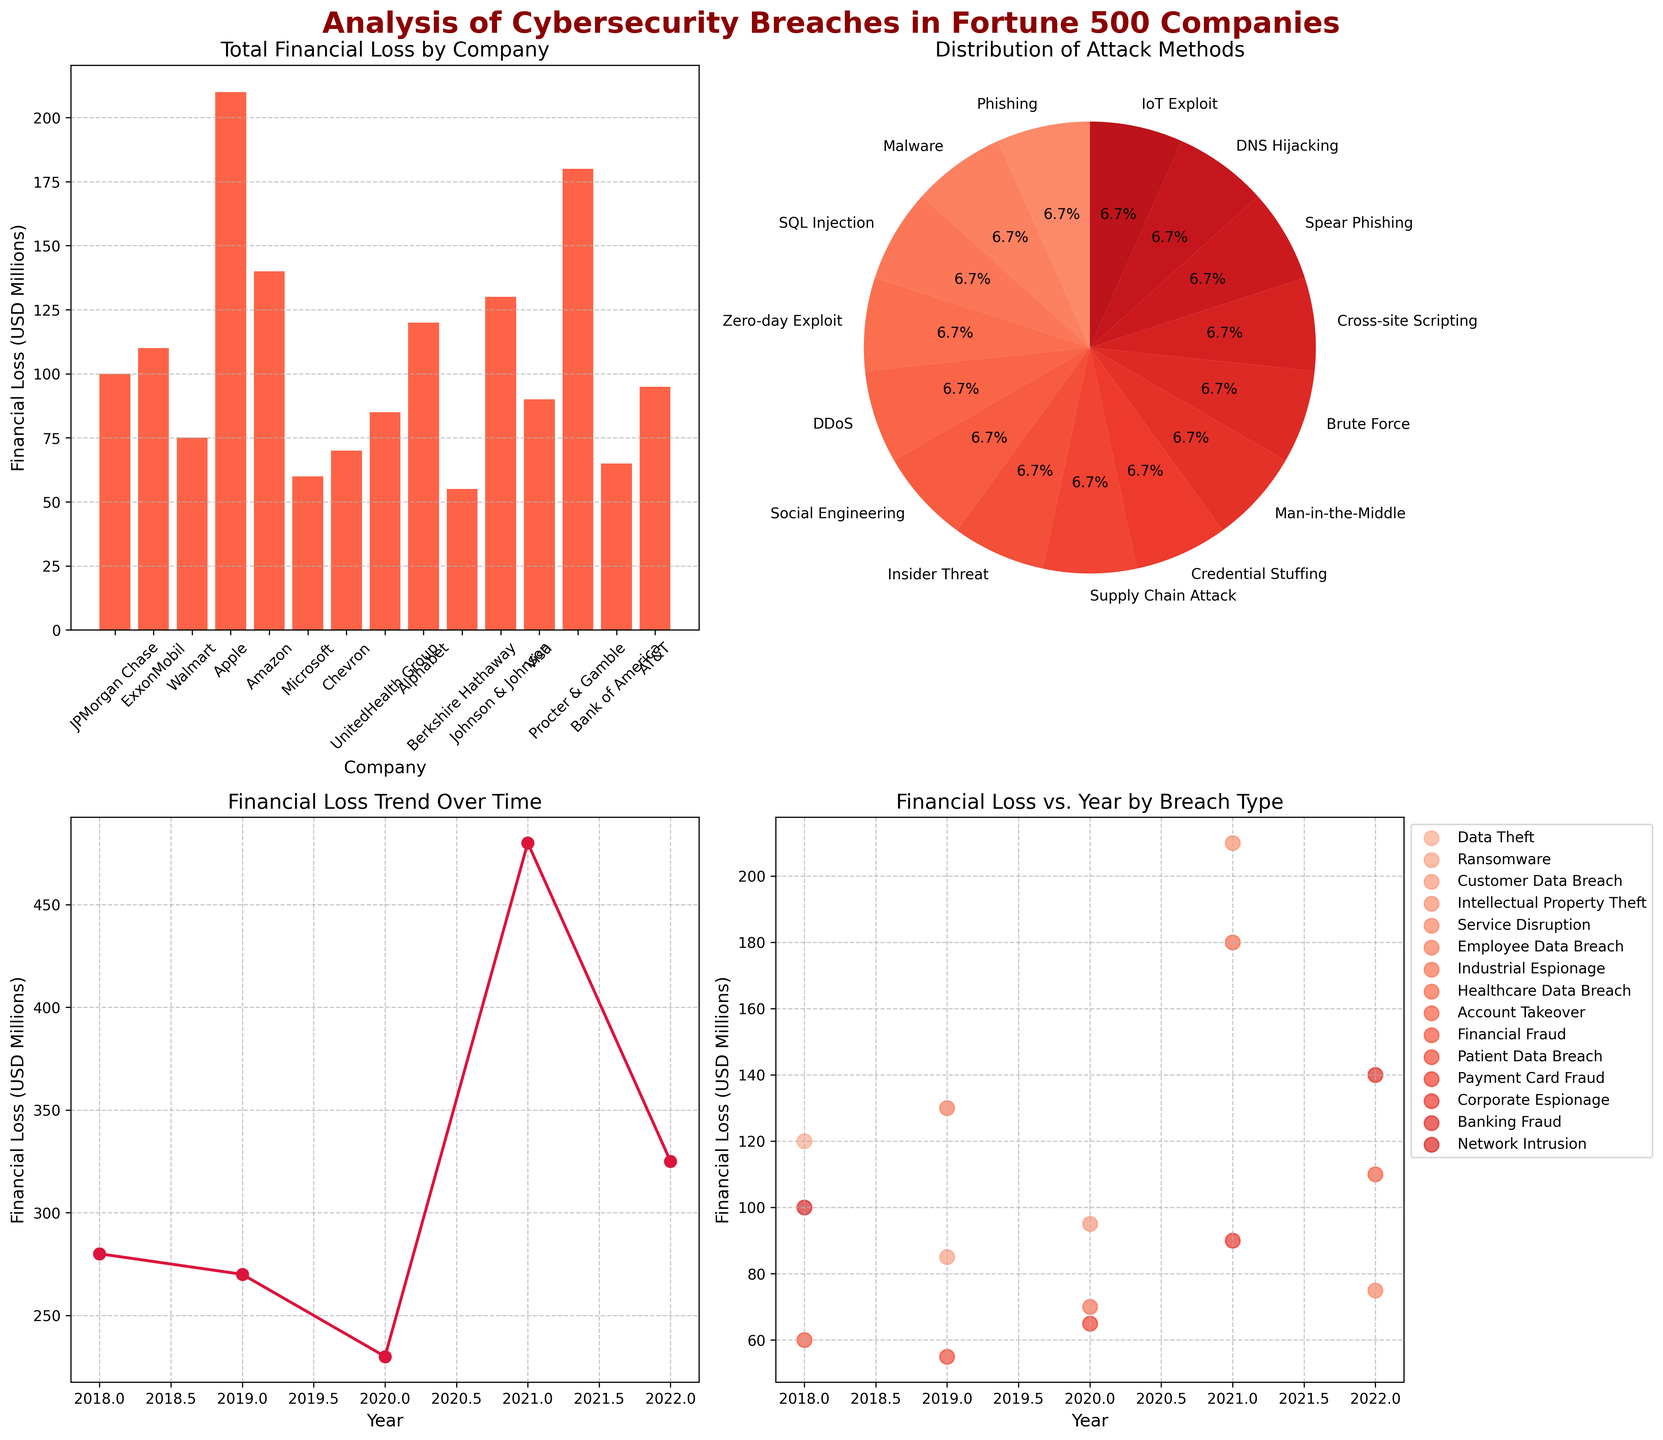What is the total financial loss for JPMorgan Chase? To find the total financial loss for JPMorgan Chase, look at the bar plot in the first subplot (top left). Locate the bar labeled "JPMorgan Chase" and read the corresponding value.
Answer: 120 million USD Which attack method has the highest percentage in the pie chart? The highest percentage slice in the pie chart (top right) indicates the most prevalent attack method. Look for the largest slice and read its label.
Answer: Social Engineering Describe the trend in financial losses over time. Examine the line plot (bottom left) which shows financial loss over time. Notice how the line moves from 2018 to 2022. The line generally increases, spikes sharply in some years, suggesting variability in financial losses over time.
Answer: Increasing with fluctuations Which company experienced the lowest financial loss? In the first subplot (top left), find the shortest bar, representing the company with the lowest total financial loss. The company below this bar is the one with the lowest financial loss.
Answer: Johnson & Johnson How much financial loss did Apple incur in 2021, and what breach type caused it? In the scatter plot (bottom right), identify the points corresponding to the year 2021. Focus on the point with the highest financial loss, which represents Apple. Read the financial loss and the associated breach type shown in the legend.
Answer: 210 million USD, Intellectual Property Theft Compare the financial losses of ransomware in 2019 and phishing in 2018. Which one was higher, and by how much? Check the scatter plot (bottom right) for data points labeled "Ransomware" in 2019 and "Phishing" in 2018. Compare the financial loss values. Ransomware in 2019 (85 million USD) versus phishing in 2018 (120 million USD); phishing incurred a higher loss.
Answer: 35 million USD higher What is the total combined financial loss from social engineering and insider threat attacks? Identify the financial losses from social engineering and insider threat methods in the various subplots. Sum the losses, from Microsoft in 2019 (130 million USD) and Chevron in 2020 (70 million USD).
Answer: 200 million USD Which year saw the highest financial loss, and what was the total for that year? Analyze the line plot (bottom left) for the peak value over the years 2018-2022. The highest point indicates the year with the maximum financial loss. Sum the values corresponding to this year from the line plot.
Answer: 2021, 480 million USD How do the financial losses from network intrusion in 2018 compare to customer data breach in 2020? Examine the scatter plot (bottom right) for points labeled "Network Intrusion" in 2018 and "Customer Data Breach" in 2020. Read the financial loss values for comparison: Network Intrusion (100 million USD) and Customer Data Breach (95 million USD).
Answer: Network Intrusion is 5 million USD higher 